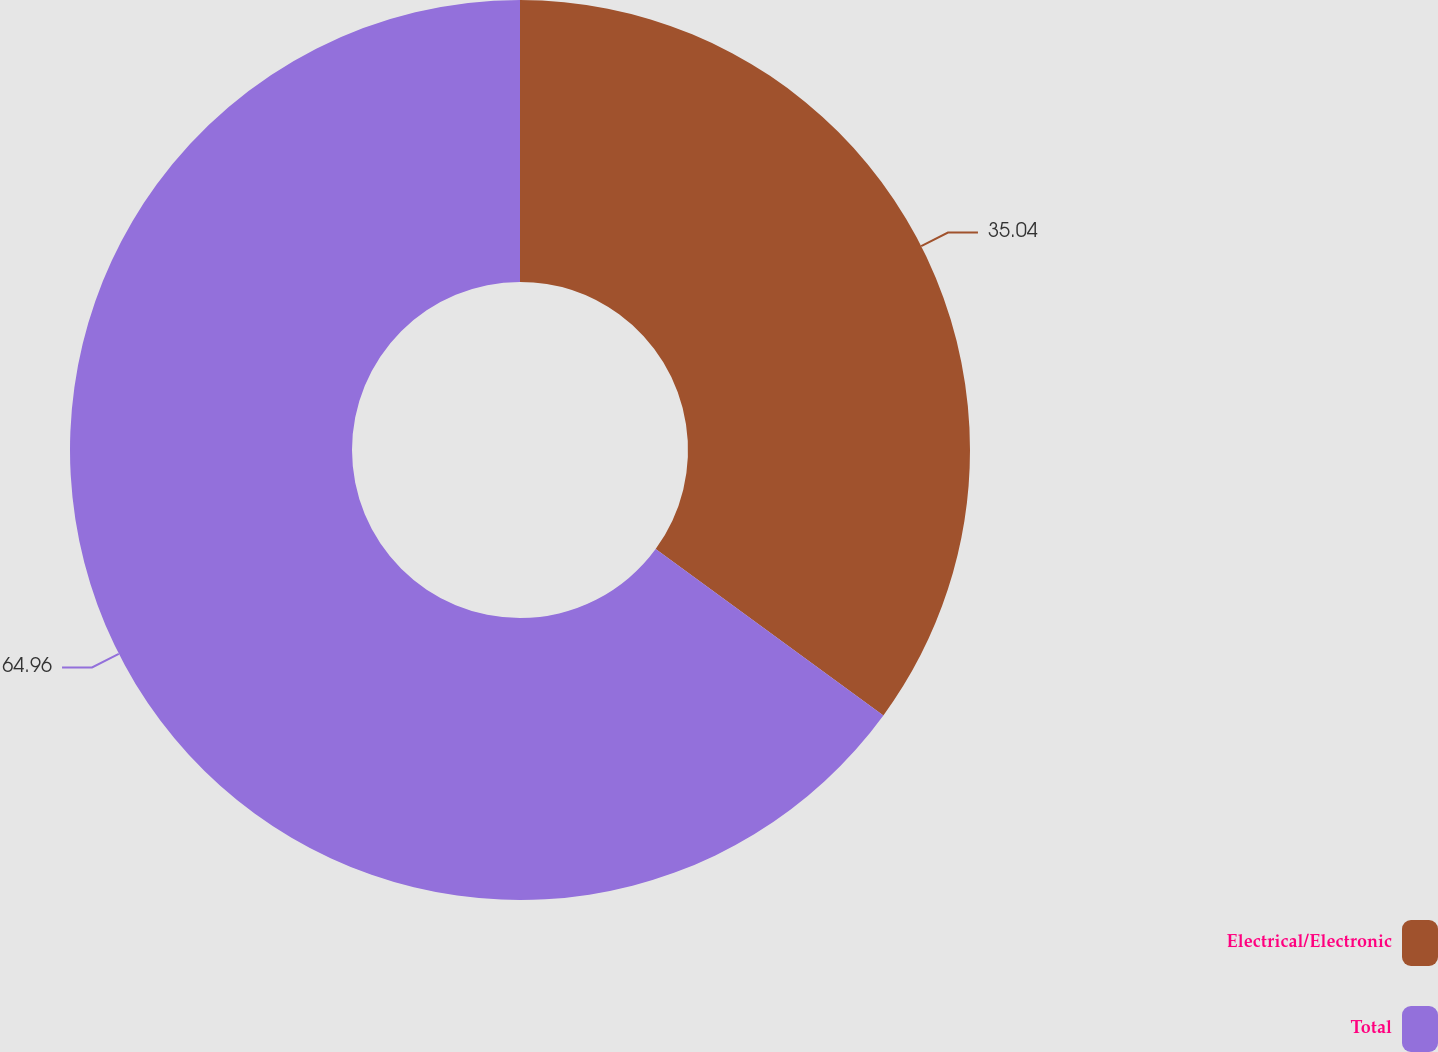<chart> <loc_0><loc_0><loc_500><loc_500><pie_chart><fcel>Electrical/Electronic<fcel>Total<nl><fcel>35.04%<fcel>64.96%<nl></chart> 